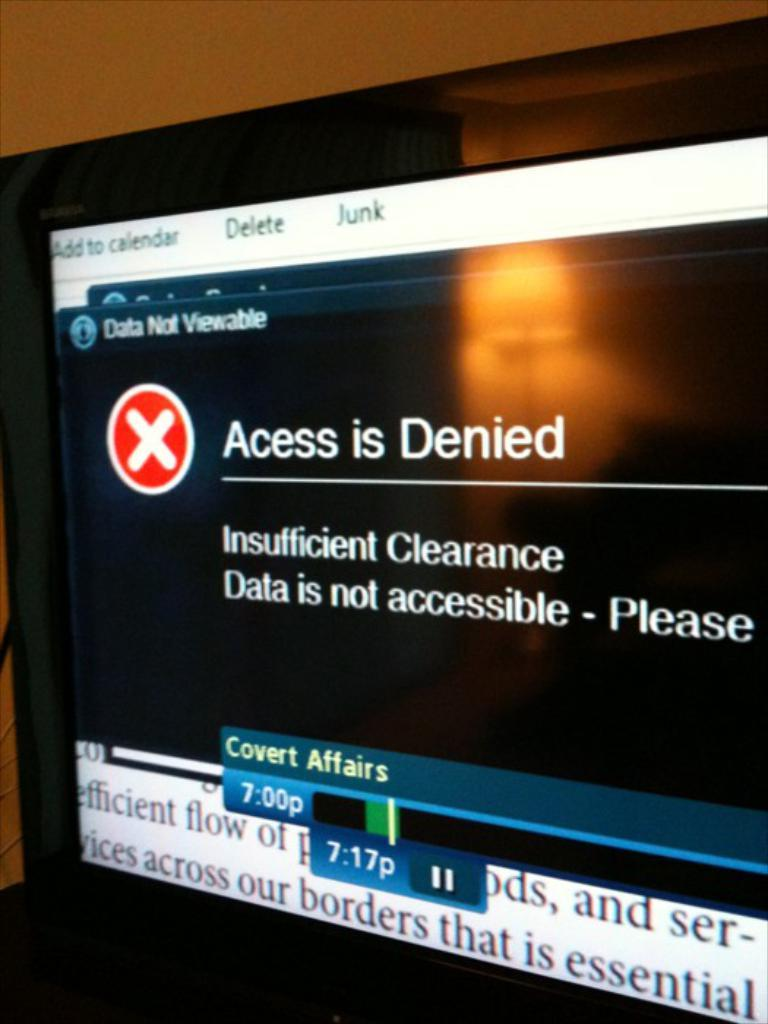<image>
Describe the image concisely. Television Screen that has Covert Affairs on DVR, and the screen says Access is Denied Insufficient Clearance, Data is not accessible- Please... 